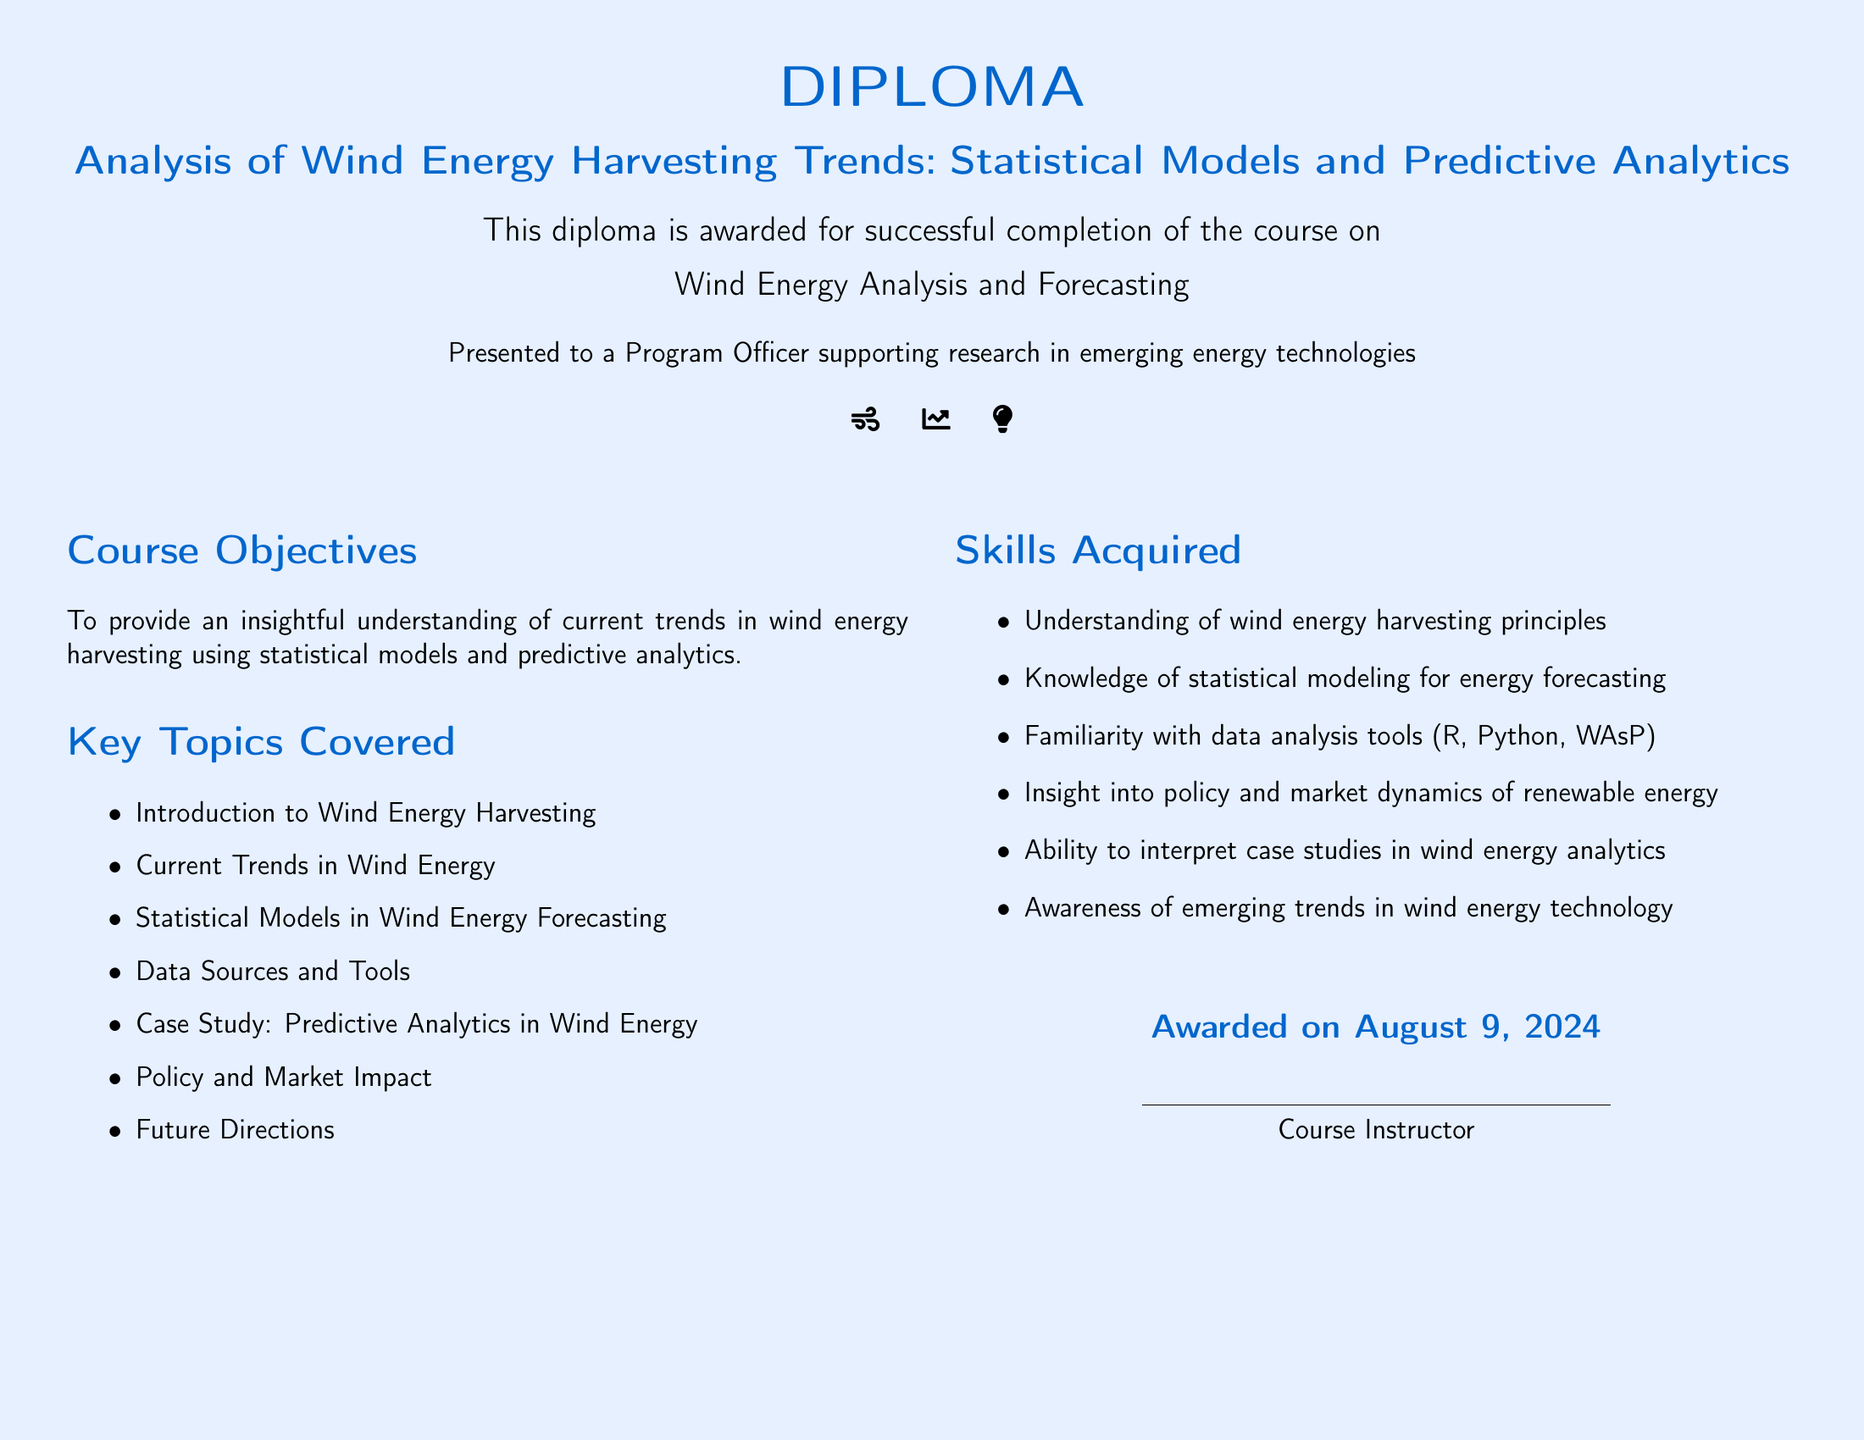what is the title of the diploma? The title of the diploma is prominently displayed in the document, indicating the focus on wind energy analysis.
Answer: Analysis of Wind Energy Harvesting Trends: Statistical Models and Predictive Analytics who is the diploma awarded to? The recipient of the diploma is specified in the text.
Answer: a Program Officer supporting research in emerging energy technologies what date is the diploma awarded on? The diploma indicates the date it is awarded as the current date when accessed.
Answer: today's date how many key topics are covered in the course? The number of key topics is listed in the document under "Key Topics Covered".
Answer: 7 name one skill acquired through this course. The skills acquired are specified in the section dedicated to Skills Acquired.
Answer: Understanding of wind energy harvesting principles what color is used for the wind energy title? The color associated with the title is specifically denoted in the document.
Answer: windblue which tool is mentioned for data analysis? One of the tools listed under Skills Acquired for data analysis is found in the document.
Answer: Python 